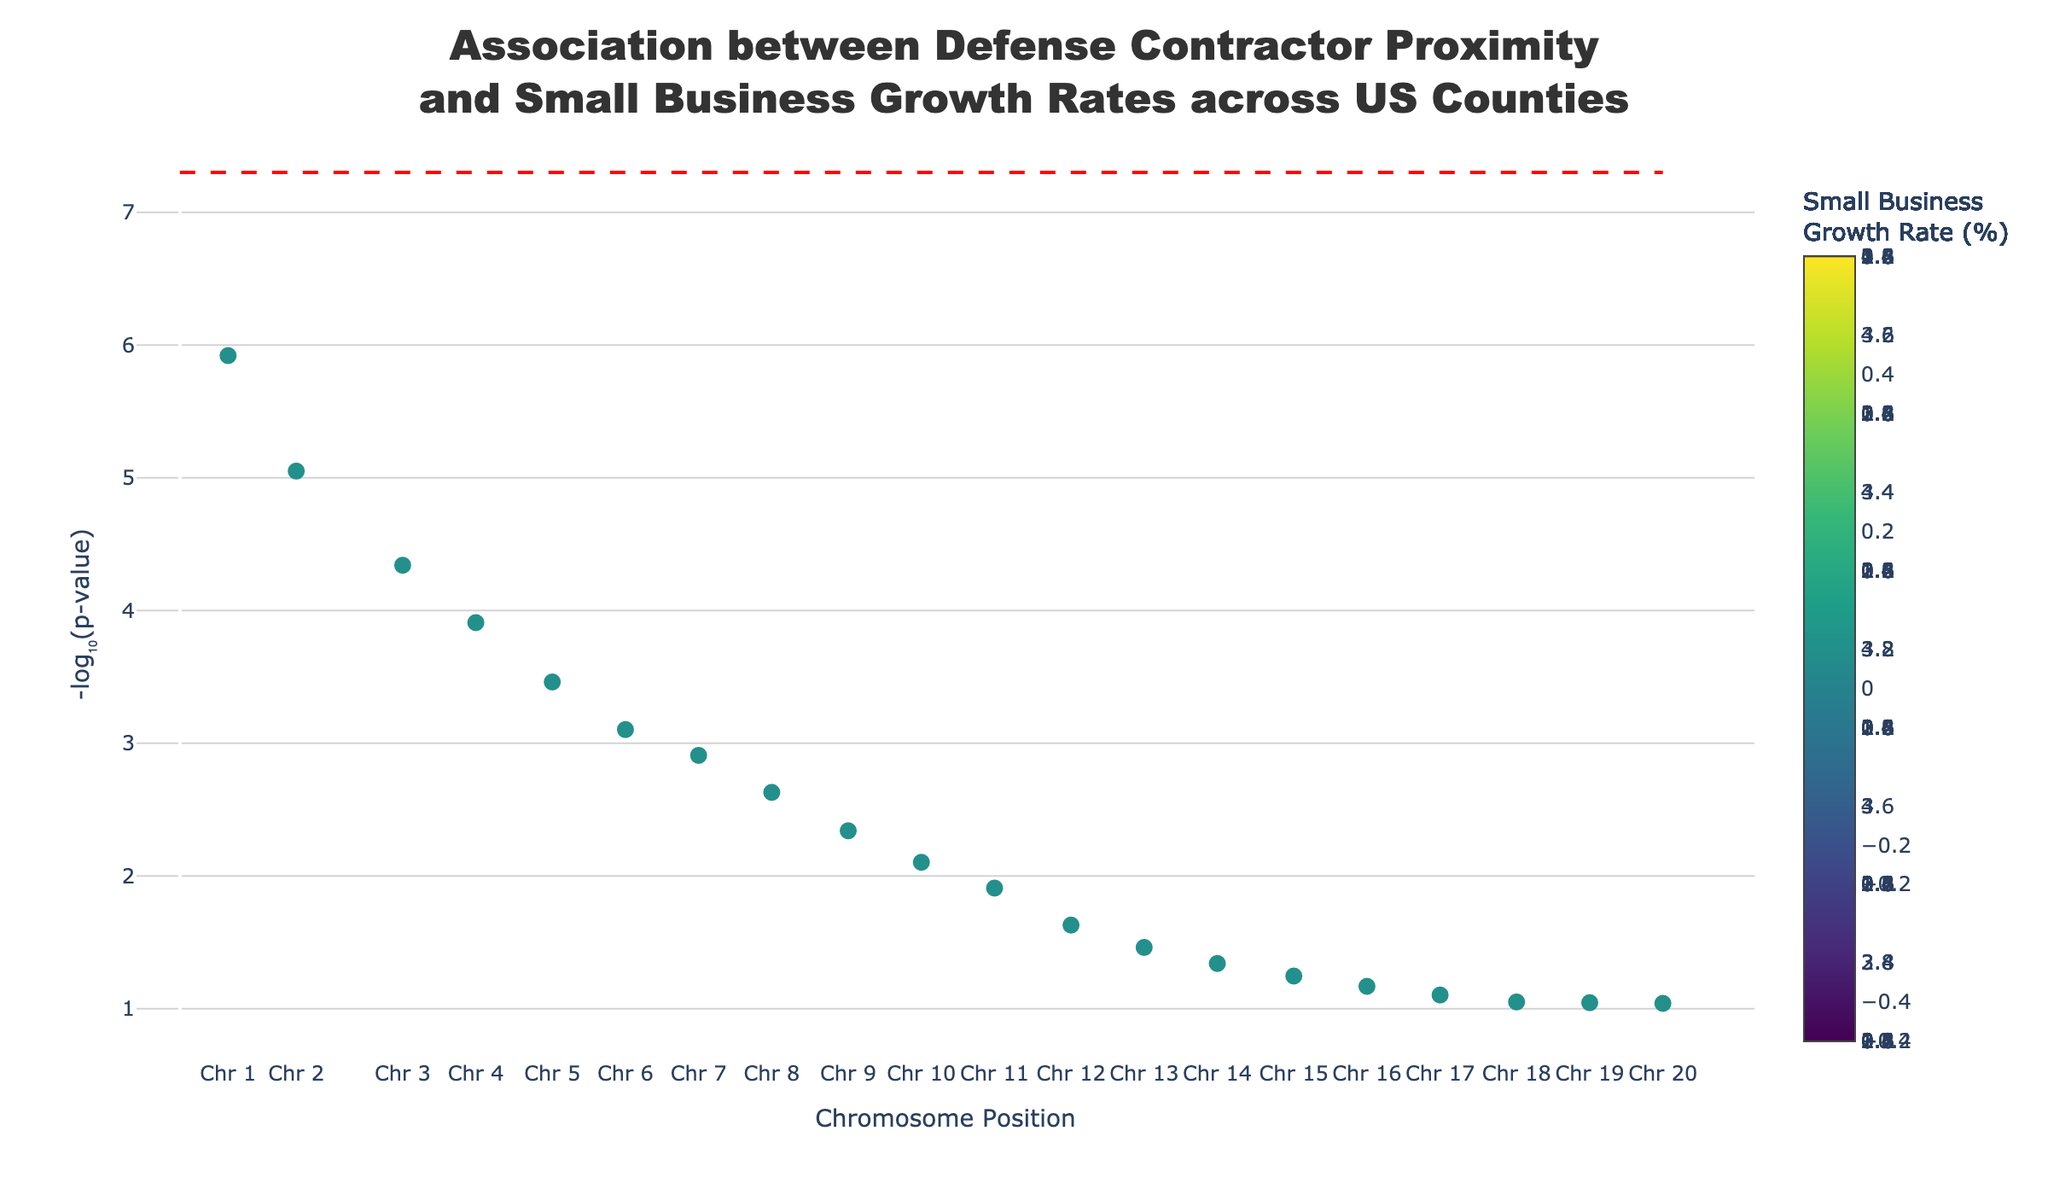What is the title of the figure? The title is located at the top of the figure, where it describes the overall content and focus of the plot, which is a common feature in any plot.
Answer: Association between Defense Contractor Proximity and Small Business Growth Rates across US Counties What does the y-axis represent? The y-axis typically denotes the dependent variable in a plot. Here it corresponds to the negative logarithm of the p-value (-log10(p-value)). This helps highlight significant associations more clearly, as lower p-values appear higher on the plot.
Answer: -log₁₀(p-value) How is small business growth rate represented in the plot? Small business growth rate is indicated by the color of the markers, with a color scale provided to interpret different growth rates. Darker colors on the Viridis scale indicate higher growth rates.
Answer: By the color of the markers What is the significance level indicated by the red dashed line? The red dashed line is a common feature in Manhattan plots, marking a standard significance threshold. Here, it indicates the level of significance against which the p-values are compared. The y-position of this line represents -log10(5e-8), a common stringent threshold for genetic association studies.
Answer: The red dashed line indicates a significance level of -log10(5e-8) Which county associated with Northrop Grumman has the highest small business growth rate? By locating markers associated with Northrop Grumman and comparing their growth rates using the color scale (darker colors represent higher rates), we identify Fairfax County in VA as the one with the highest growth rate.
Answer: Fairfax County, VA Which chromosome has the largest number of marked positions? By visually inspecting the plot and counting the number of data points (markers) associated with each chromosome, we find that chromosomes appear to be distributed equally with each having one marker. Therefore, it’s hard to say one chromosome stands out over others based on this data.
Answer: All chromosomes have an equal number of markers What small business growth rate corresponds to a p-value of 0.0000012? To find the specific growth rate corresponding to a known p-value, locate the data point with a p-value of 0.0000012 on the plot and refer to its marker’s color or associated data. This maps directly to Fairfax County, VA, linked to Northrop Grumman with a growth rate of 4.2%.
Answer: 4.2% How do the growth rates of counties associated with Boeing compare? To answer this, identify all counties associated with Boeing by examining the hover text or legend and comparing their growth rates. The counties involved are King County, WA (3.5%), Madison County, AL (2.1%), St. Louis County, MO (1.7%), and Okaloosa County, FL (0.5%), sorted here by declining growth rates.
Answer: 3.5%, 2.1%, 1.7%, 0.5% What is the overall trend between the significance of association and small business growth rates? Observing the colors of the markers as well as their positions along the y-axis, markers with higher y-values (more significant p-values) tend to have darker colors, indicating higher growth rates. Thus, there’s a general trend that higher significance corresponds to higher growth rates.
Answer: Higher significance associations correspond to higher small business growth rates 